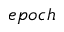<formula> <loc_0><loc_0><loc_500><loc_500>e p o c h</formula> 